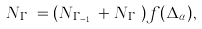Convert formula to latex. <formula><loc_0><loc_0><loc_500><loc_500>N _ { \Gamma _ { n } } = ( N _ { \Gamma _ { n - 1 } } + N _ { \Gamma _ { n } } ) f ( \Delta _ { \alpha } ) ,</formula> 